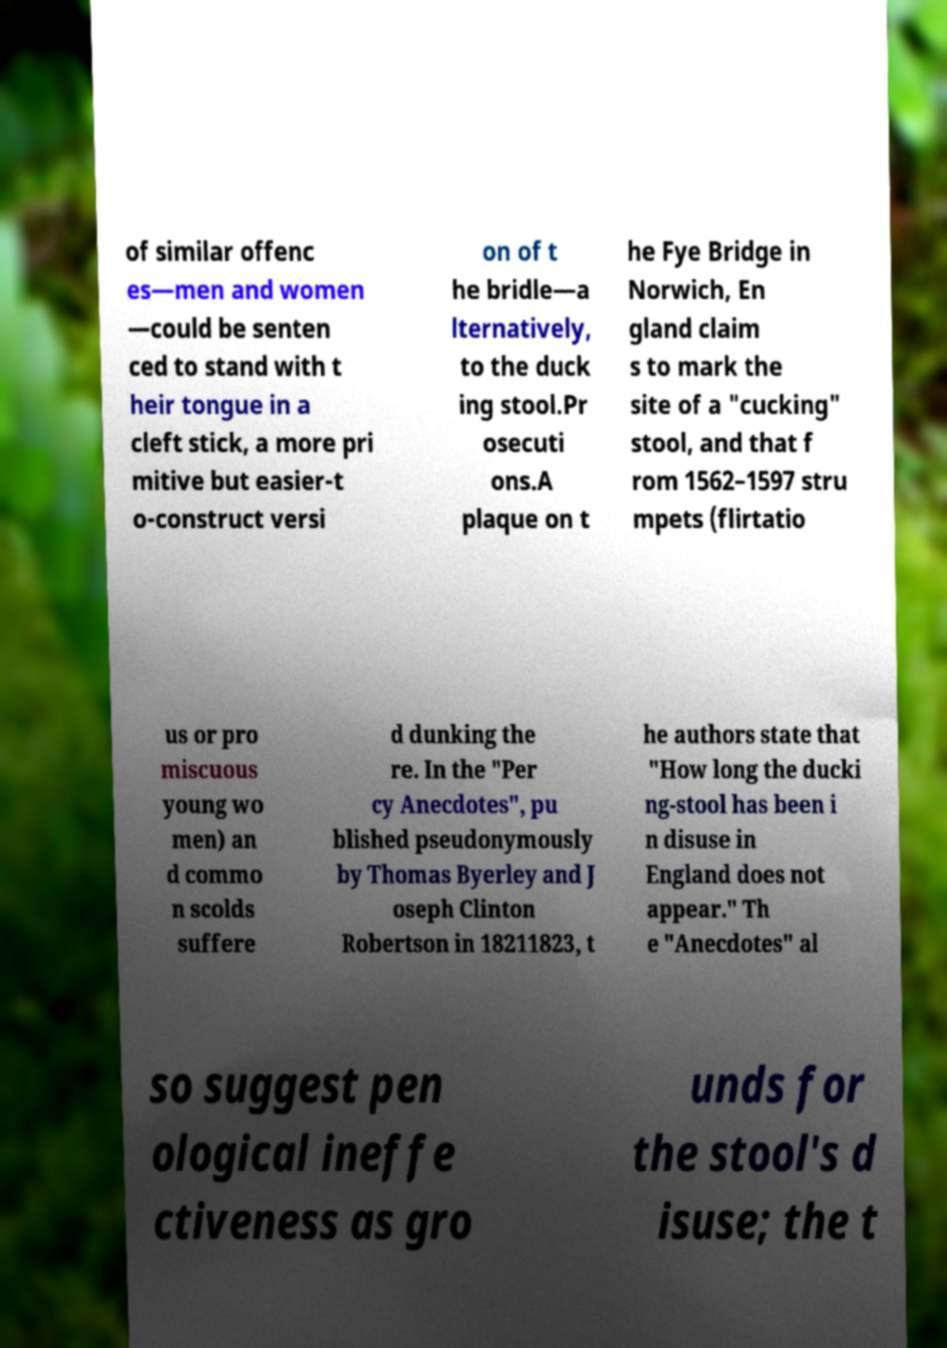What messages or text are displayed in this image? I need them in a readable, typed format. of similar offenc es—men and women —could be senten ced to stand with t heir tongue in a cleft stick, a more pri mitive but easier-t o-construct versi on of t he bridle—a lternatively, to the duck ing stool.Pr osecuti ons.A plaque on t he Fye Bridge in Norwich, En gland claim s to mark the site of a "cucking" stool, and that f rom 1562–1597 stru mpets (flirtatio us or pro miscuous young wo men) an d commo n scolds suffere d dunking the re. In the "Per cy Anecdotes", pu blished pseudonymously by Thomas Byerley and J oseph Clinton Robertson in 18211823, t he authors state that "How long the ducki ng-stool has been i n disuse in England does not appear." Th e "Anecdotes" al so suggest pen ological ineffe ctiveness as gro unds for the stool's d isuse; the t 